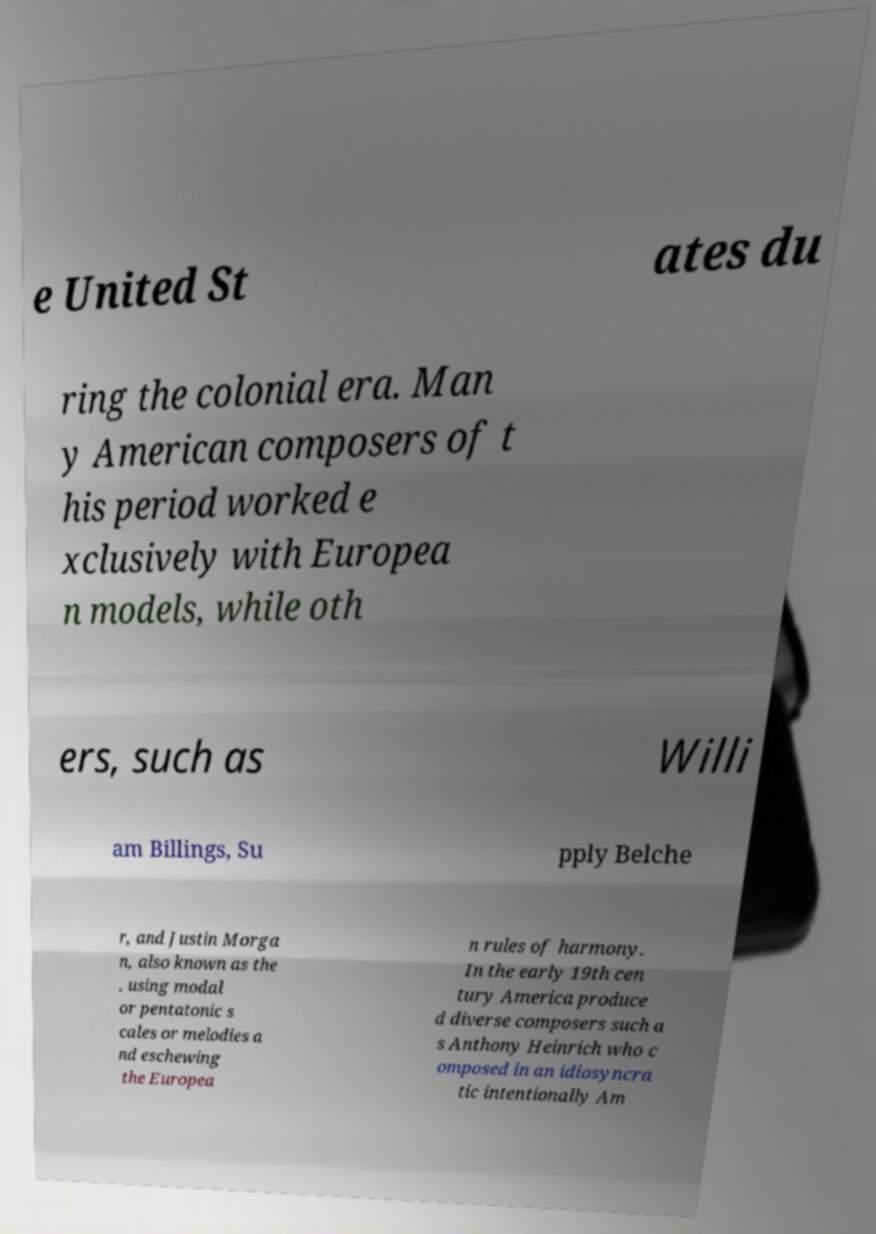There's text embedded in this image that I need extracted. Can you transcribe it verbatim? e United St ates du ring the colonial era. Man y American composers of t his period worked e xclusively with Europea n models, while oth ers, such as Willi am Billings, Su pply Belche r, and Justin Morga n, also known as the , using modal or pentatonic s cales or melodies a nd eschewing the Europea n rules of harmony. In the early 19th cen tury America produce d diverse composers such a s Anthony Heinrich who c omposed in an idiosyncra tic intentionally Am 